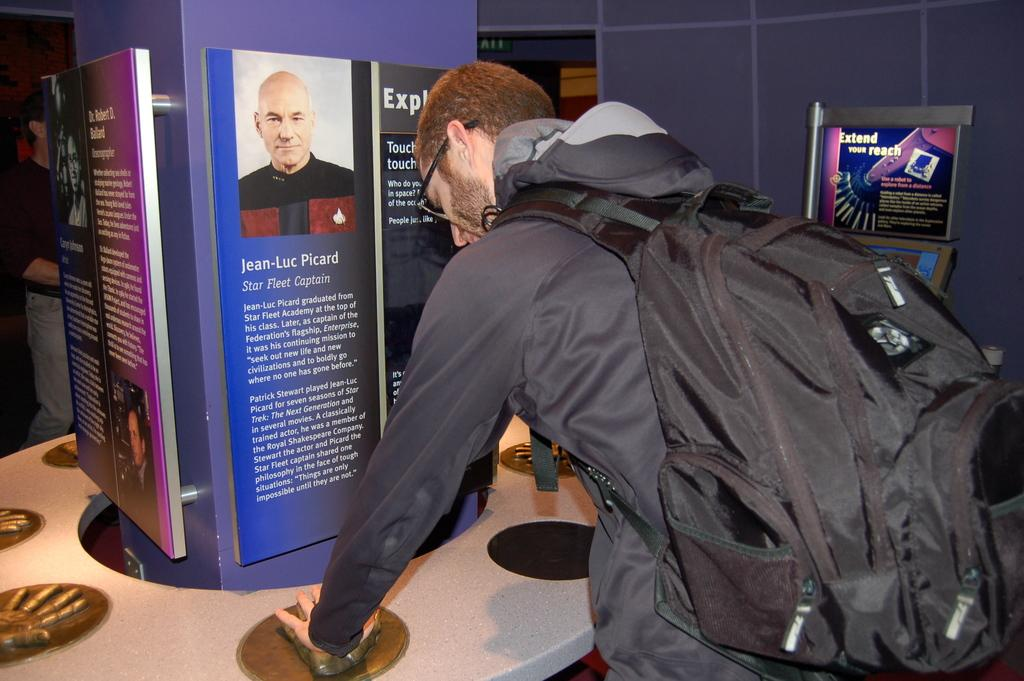Who is present in the image? There is a man in the image. What is the man wearing? The man is wearing a bag. What is the man doing in the image? The man is printing his hand on a mould. Is there any additional information visible in the image? Yes, there is a banner in front of the man. What type of canvas is the man using to print his hand on? There is no canvas present in the image; the man is printing his hand on a mould. Is the man wearing a mask in the image? No, the man is not wearing a mask in the image. 